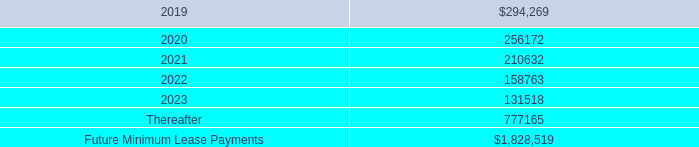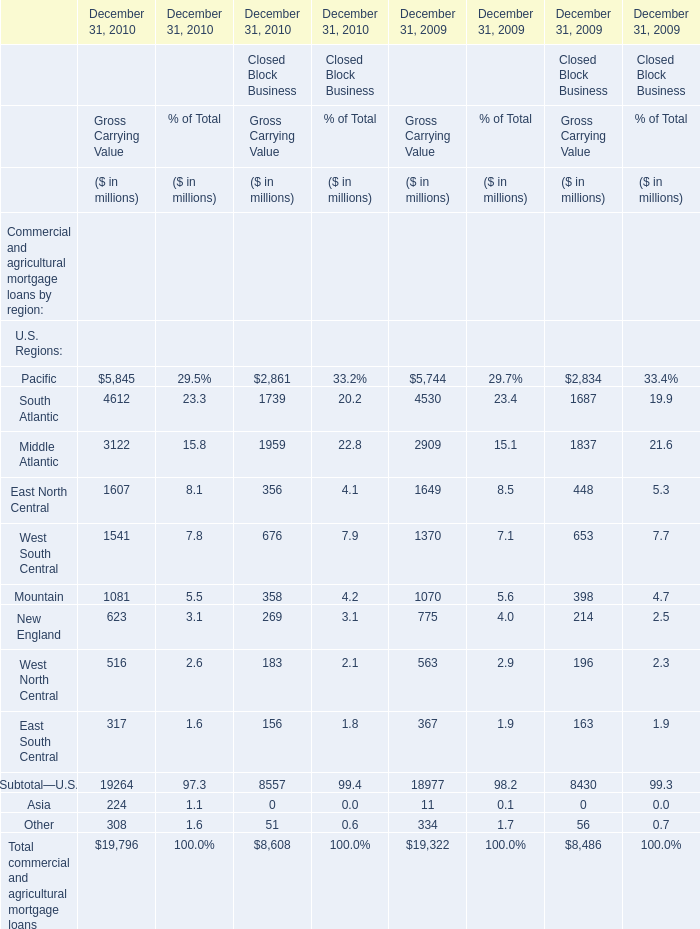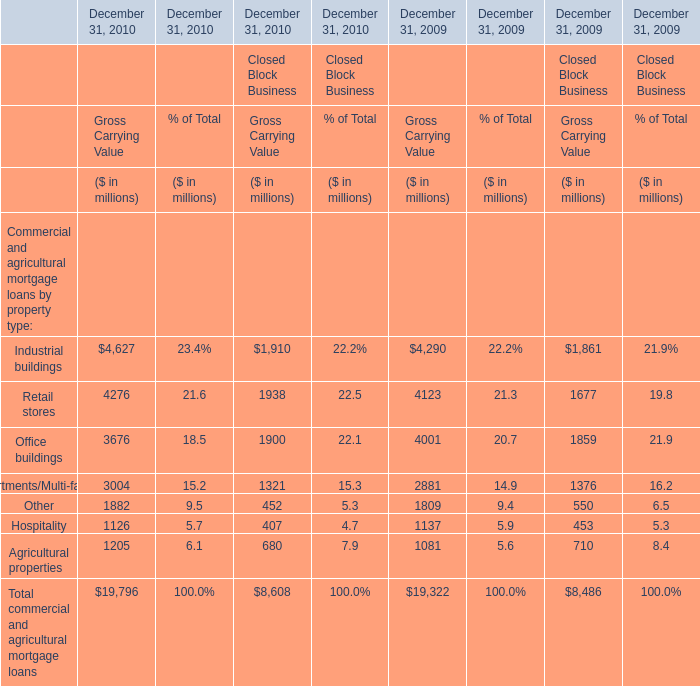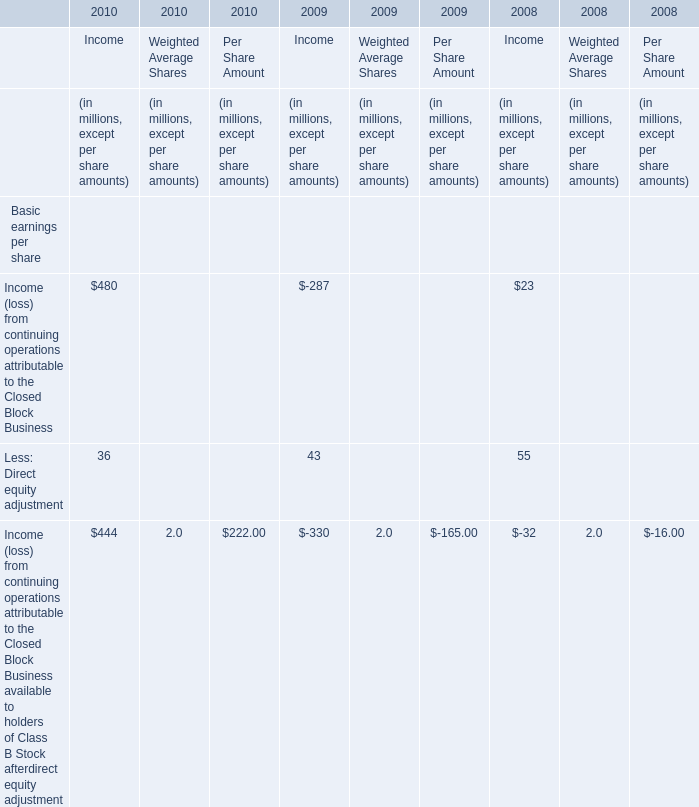Which year is the Gross Carrying Value in terms of Financial Services Businesses for Commercial and agricultural mortgage loans by property type:Retail stores on December 31 the largest? 
Answer: 2010. 